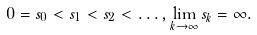Convert formula to latex. <formula><loc_0><loc_0><loc_500><loc_500>0 = s _ { 0 } < s _ { 1 } < s _ { 2 } < \dots , \lim _ { k \to \infty } s _ { k } = \infty .</formula> 